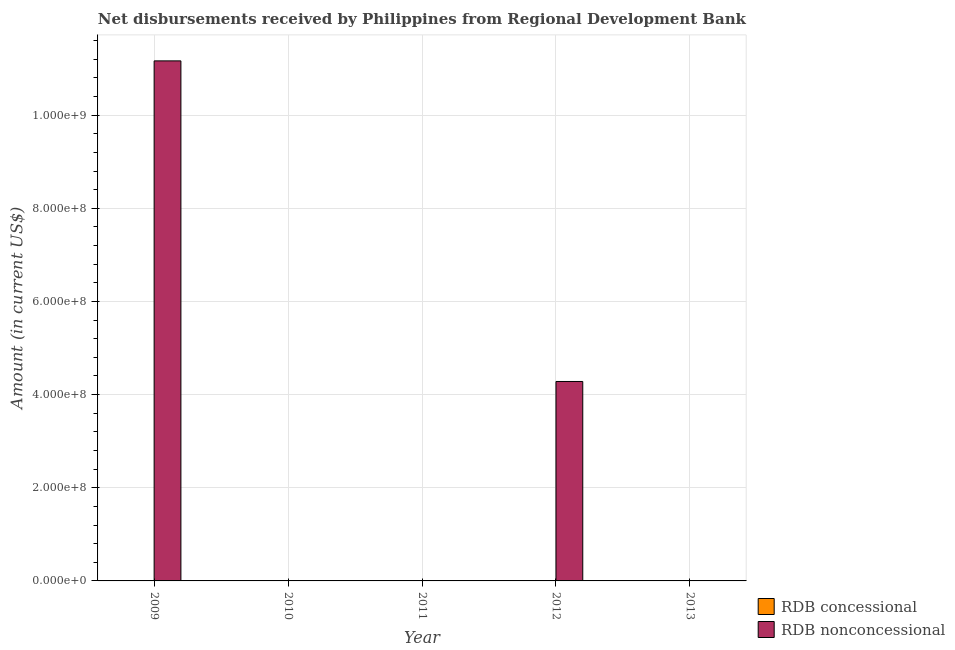How many bars are there on the 4th tick from the left?
Ensure brevity in your answer.  1. What is the label of the 5th group of bars from the left?
Provide a short and direct response. 2013. In how many cases, is the number of bars for a given year not equal to the number of legend labels?
Keep it short and to the point. 5. What is the net concessional disbursements from rdb in 2011?
Ensure brevity in your answer.  0. Across all years, what is the maximum net non concessional disbursements from rdb?
Your response must be concise. 1.12e+09. Across all years, what is the minimum net non concessional disbursements from rdb?
Your answer should be very brief. 0. What is the total net non concessional disbursements from rdb in the graph?
Give a very brief answer. 1.54e+09. What is the difference between the net non concessional disbursements from rdb in 2012 and the net concessional disbursements from rdb in 2013?
Keep it short and to the point. 4.28e+08. What is the average net concessional disbursements from rdb per year?
Your answer should be compact. 0. In the year 2009, what is the difference between the net non concessional disbursements from rdb and net concessional disbursements from rdb?
Provide a short and direct response. 0. In how many years, is the net concessional disbursements from rdb greater than 600000000 US$?
Give a very brief answer. 0. What is the ratio of the net non concessional disbursements from rdb in 2009 to that in 2012?
Make the answer very short. 2.61. What is the difference between the highest and the lowest net non concessional disbursements from rdb?
Your response must be concise. 1.12e+09. In how many years, is the net concessional disbursements from rdb greater than the average net concessional disbursements from rdb taken over all years?
Your response must be concise. 0. Is the sum of the net non concessional disbursements from rdb in 2009 and 2012 greater than the maximum net concessional disbursements from rdb across all years?
Ensure brevity in your answer.  Yes. Are all the bars in the graph horizontal?
Provide a short and direct response. No. How many years are there in the graph?
Your answer should be compact. 5. Are the values on the major ticks of Y-axis written in scientific E-notation?
Ensure brevity in your answer.  Yes. Does the graph contain any zero values?
Give a very brief answer. Yes. Where does the legend appear in the graph?
Ensure brevity in your answer.  Bottom right. How many legend labels are there?
Ensure brevity in your answer.  2. What is the title of the graph?
Make the answer very short. Net disbursements received by Philippines from Regional Development Bank. What is the label or title of the X-axis?
Offer a very short reply. Year. What is the label or title of the Y-axis?
Your answer should be very brief. Amount (in current US$). What is the Amount (in current US$) in RDB nonconcessional in 2009?
Make the answer very short. 1.12e+09. What is the Amount (in current US$) of RDB concessional in 2010?
Provide a short and direct response. 0. What is the Amount (in current US$) of RDB concessional in 2011?
Offer a very short reply. 0. What is the Amount (in current US$) of RDB nonconcessional in 2011?
Give a very brief answer. 0. What is the Amount (in current US$) in RDB nonconcessional in 2012?
Offer a very short reply. 4.28e+08. What is the Amount (in current US$) of RDB concessional in 2013?
Your answer should be very brief. 0. What is the Amount (in current US$) in RDB nonconcessional in 2013?
Offer a terse response. 0. Across all years, what is the maximum Amount (in current US$) of RDB nonconcessional?
Provide a short and direct response. 1.12e+09. What is the total Amount (in current US$) of RDB nonconcessional in the graph?
Keep it short and to the point. 1.54e+09. What is the difference between the Amount (in current US$) in RDB nonconcessional in 2009 and that in 2012?
Provide a short and direct response. 6.88e+08. What is the average Amount (in current US$) of RDB nonconcessional per year?
Ensure brevity in your answer.  3.09e+08. What is the ratio of the Amount (in current US$) of RDB nonconcessional in 2009 to that in 2012?
Your answer should be compact. 2.61. What is the difference between the highest and the lowest Amount (in current US$) in RDB nonconcessional?
Offer a terse response. 1.12e+09. 